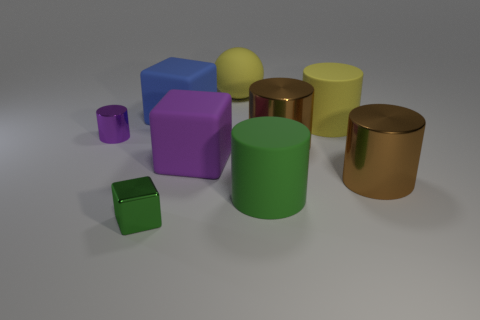Can you identify the shapes present in the image? Certainly! In the image, there are several geometric shapes visible: there're cubes (like the small purple one and the green ones), a sphere (the yellow object), and cylinders (such as the yellow and bronze-colored objects). 